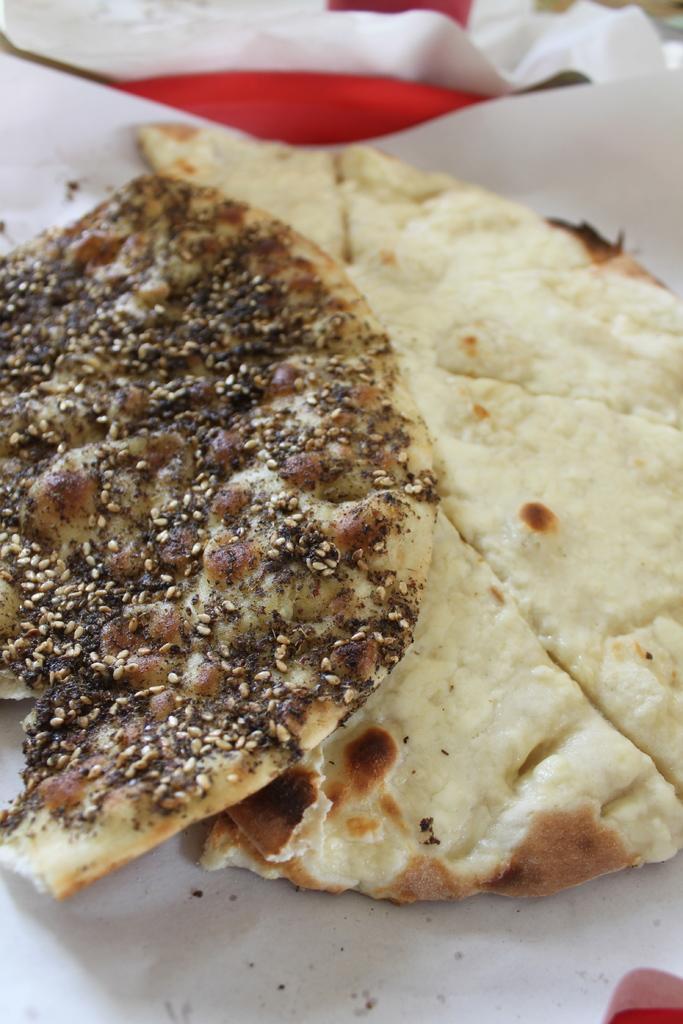Please provide a concise description of this image. In this image I can see two white colour roti and on the one roti I can see ingredients. I can also see white colour thing under these roti. 